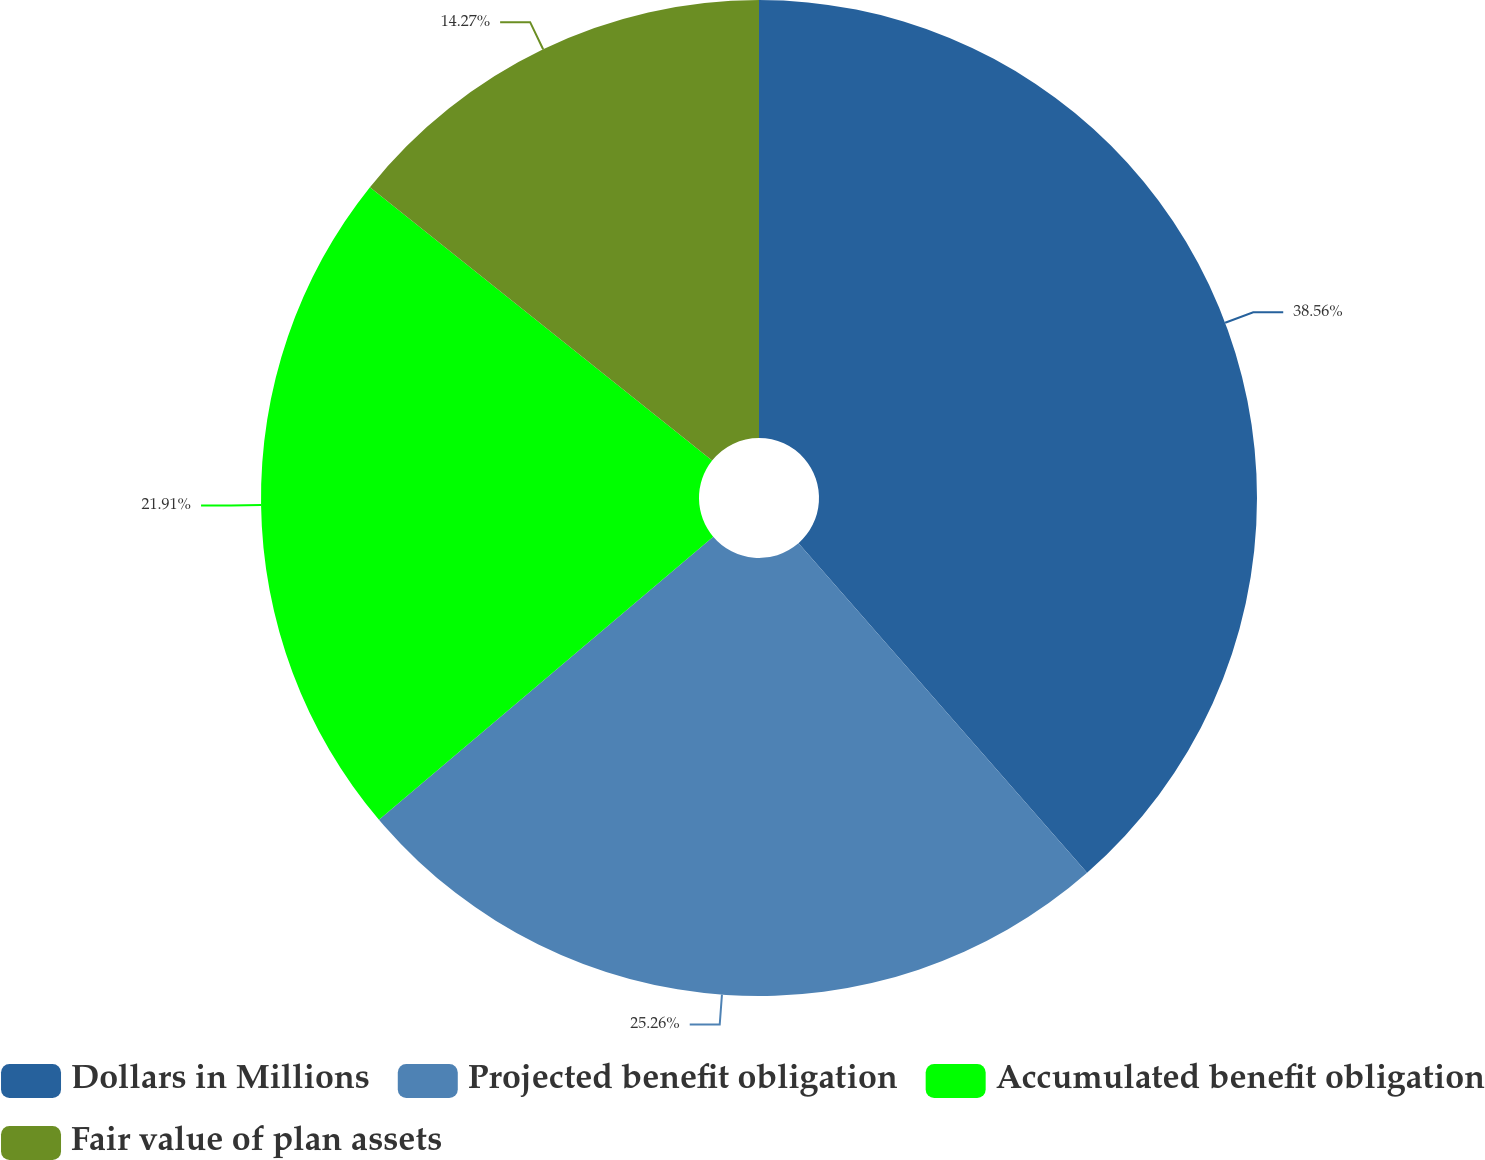Convert chart. <chart><loc_0><loc_0><loc_500><loc_500><pie_chart><fcel>Dollars in Millions<fcel>Projected benefit obligation<fcel>Accumulated benefit obligation<fcel>Fair value of plan assets<nl><fcel>38.55%<fcel>25.26%<fcel>21.91%<fcel>14.27%<nl></chart> 